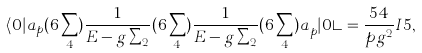Convert formula to latex. <formula><loc_0><loc_0><loc_500><loc_500>\langle 0 | a _ { p } ( 6 \sum _ { 4 } ) \frac { 1 } { E - g \sum _ { 2 } } ( 6 \sum _ { 4 } ) \frac { 1 } { E - g \sum _ { 2 } } ( 6 \sum _ { 4 } ) a _ { p } ^ { \dagger } | 0 \rangle = \frac { 5 4 } { p g ^ { 2 } } I { 5 } ,</formula> 